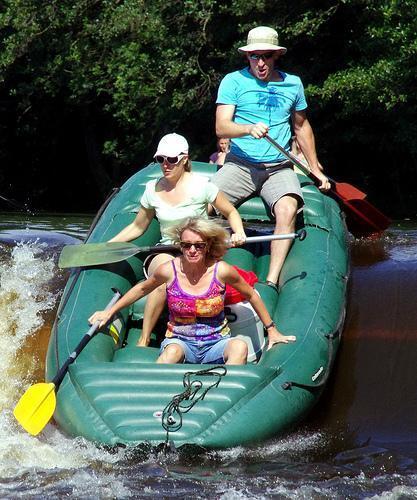How many people are in the raft?
Give a very brief answer. 3. 